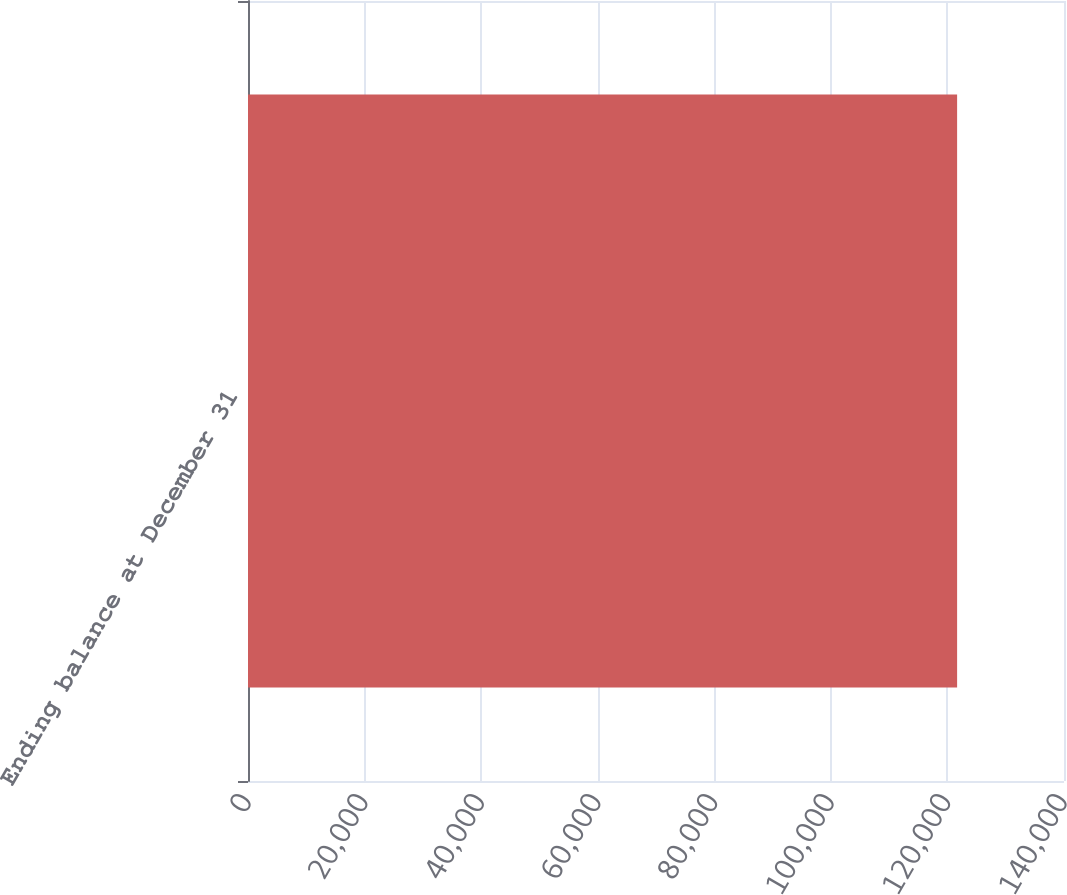Convert chart to OTSL. <chart><loc_0><loc_0><loc_500><loc_500><bar_chart><fcel>Ending balance at December 31<nl><fcel>121661<nl></chart> 